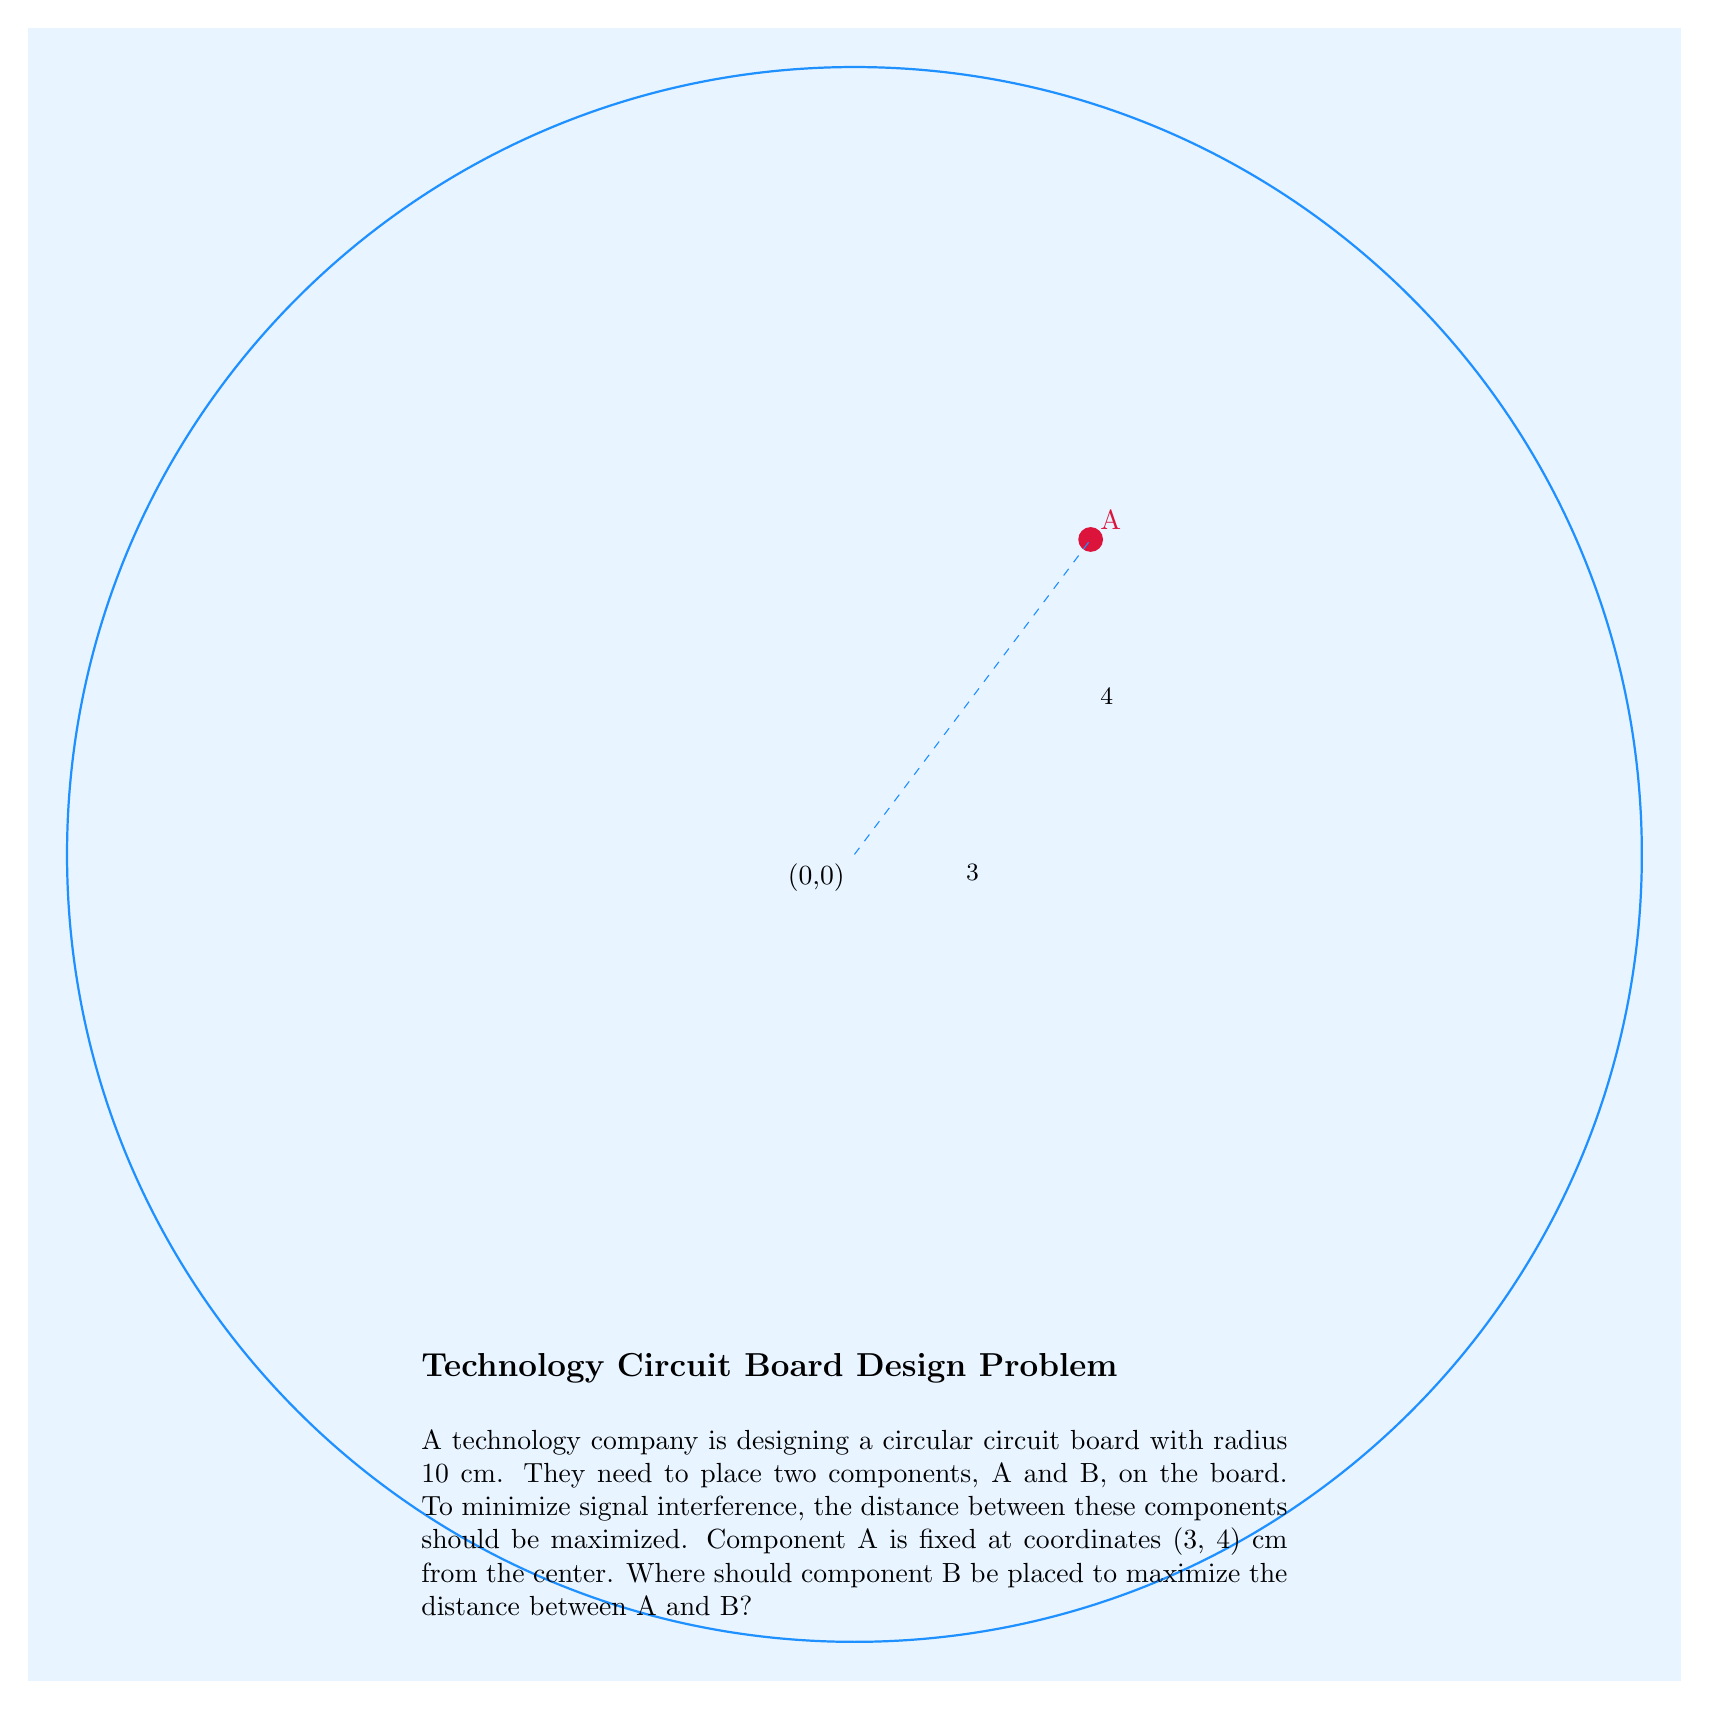Teach me how to tackle this problem. Let's approach this step-by-step:

1) The circuit board is circular with radius 10 cm. This means any point (x, y) on the edge of the board satisfies the equation:

   $$x^2 + y^2 = 10^2 = 100$$

2) Component A is at (3, 4). To maximize the distance between A and B, component B should be placed on the opposite side of the circle.

3) The center of the circle is at (0, 0). The line from (0, 0) through (3, 4) to the edge of the circle will give us the optimal position for B.

4) To find this point, we need to extend the line from (0, 0) to (3, 4) until it intersects the circle. We can do this by finding a scalar $t$ such that:

   $$(3t, 4t)$$ is on the circle.

5) Substituting into the circle equation:

   $$(3t)^2 + (4t)^2 = 100$$
   $$9t^2 + 16t^2 = 100$$
   $$25t^2 = 100$$
   $$t^2 = 4$$
   $$t = 2$$ (we take the positive value as we're extending the line)

6) Therefore, the coordinates of B are:

   $$x = 3 * 2 = 6$$
   $$y = 4 * 2 = 8$$

Thus, component B should be placed at (6, 8) cm from the center of the circuit board.
Answer: (6, 8) cm 